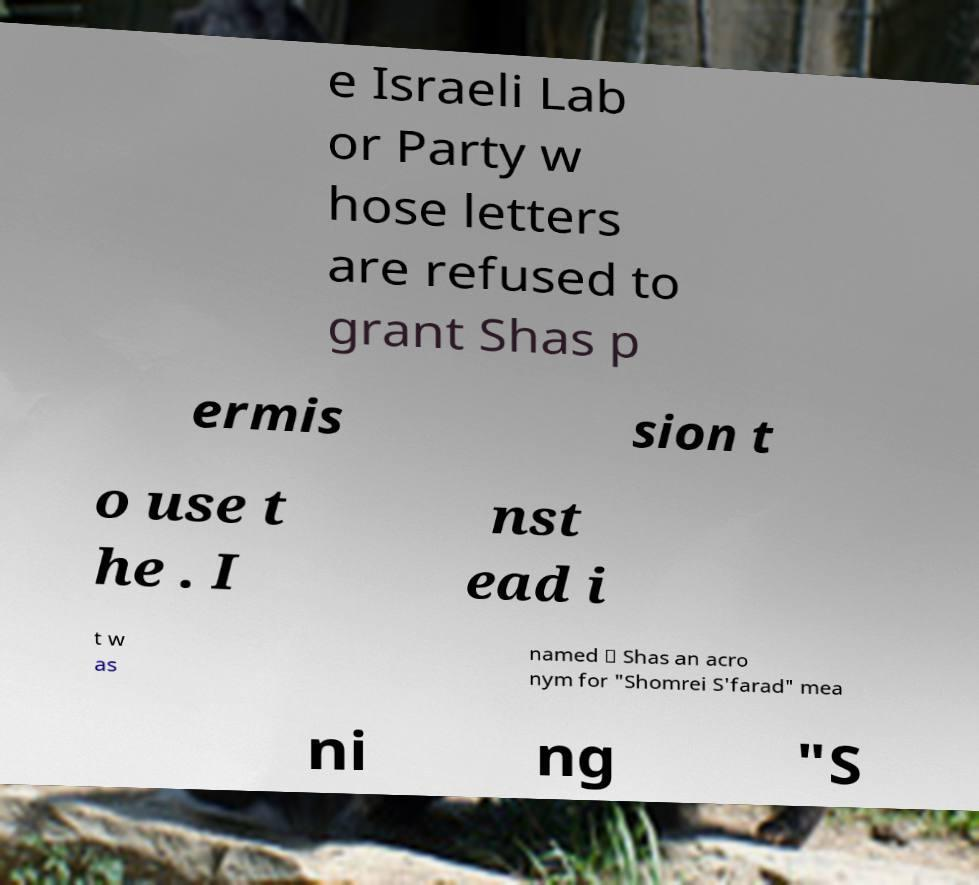Can you read and provide the text displayed in the image?This photo seems to have some interesting text. Can you extract and type it out for me? e Israeli Lab or Party w hose letters are refused to grant Shas p ermis sion t o use t he . I nst ead i t w as named ״ Shas an acro nym for "Shomrei S'farad" mea ni ng "S 